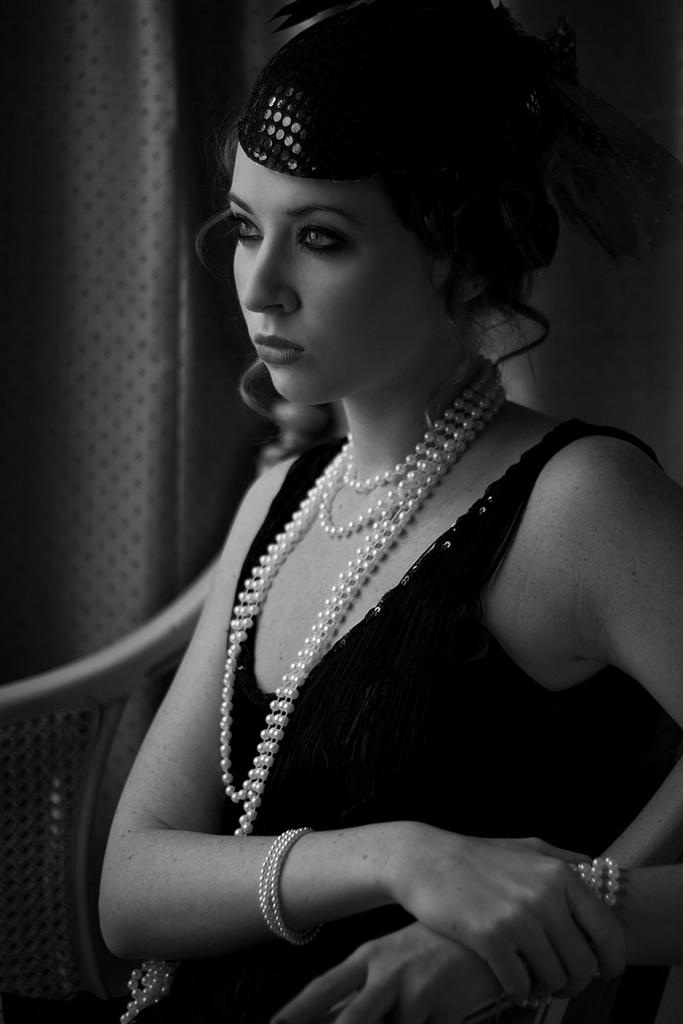What is the color scheme of the image? The image is black and white. Who is present in the image? There is a woman in the image. What is the woman doing in the image? The woman is sitting on a chair. What can be seen in the background of the image? There is a wall in the background of the image. How many apples can be seen on the wall in the image? There are no apples present in the image; it is a black and white image of a woman sitting on a chair with a wall in the background. What type of heat source is being used by the woman in the image? There is no heat source visible in the image; it is a black and white image of a woman sitting on a chair with a wall in the background. 